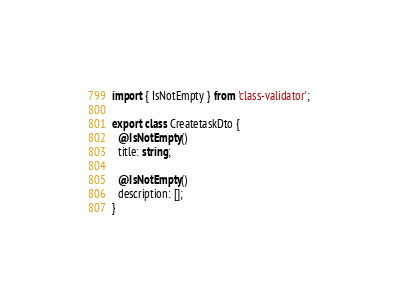Convert code to text. <code><loc_0><loc_0><loc_500><loc_500><_TypeScript_>import { IsNotEmpty } from 'class-validator';

export class CreatetaskDto {
  @IsNotEmpty()
  title: string;

  @IsNotEmpty()
  description: [];
}
</code> 